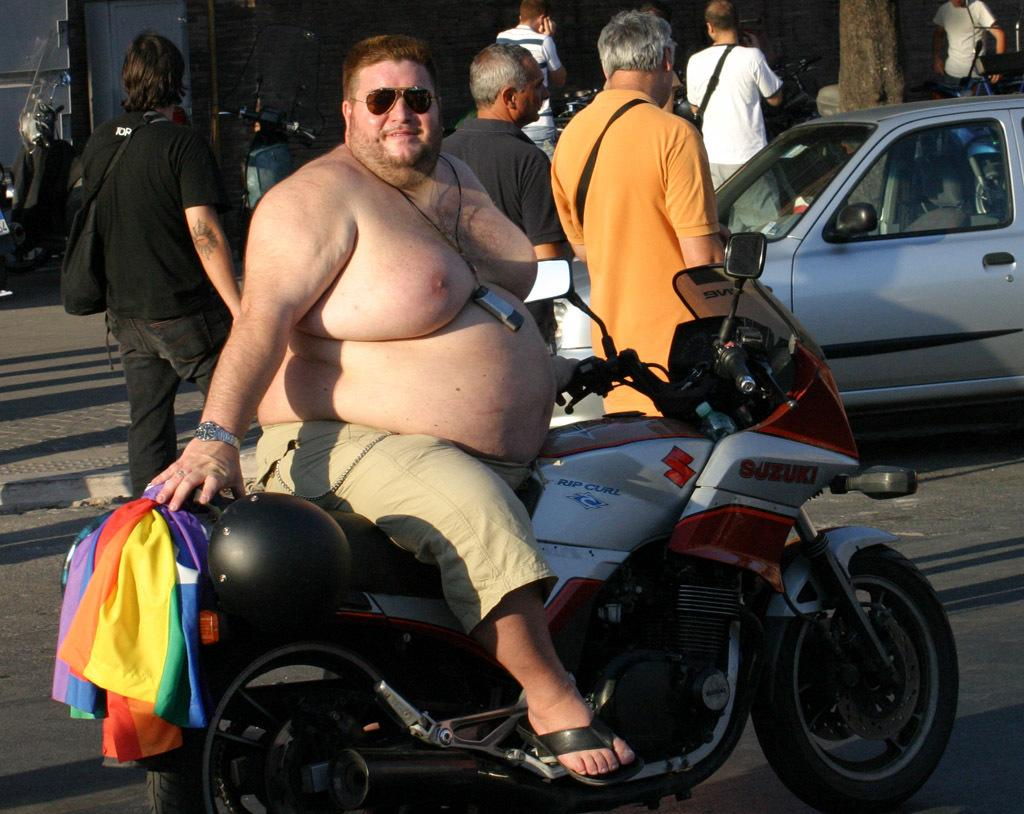What is the man in the image doing? The man is sitting on a bike in the image. What can be seen happening in the background of the image? There are people walking on the road in the background. What type of vehicle is visible in the image? There is a car visible in the image. What is present in the background of the image? There is a wall in the background of the image. What type of sail can be seen on the truck in the image? There is no truck or sail present in the image. 